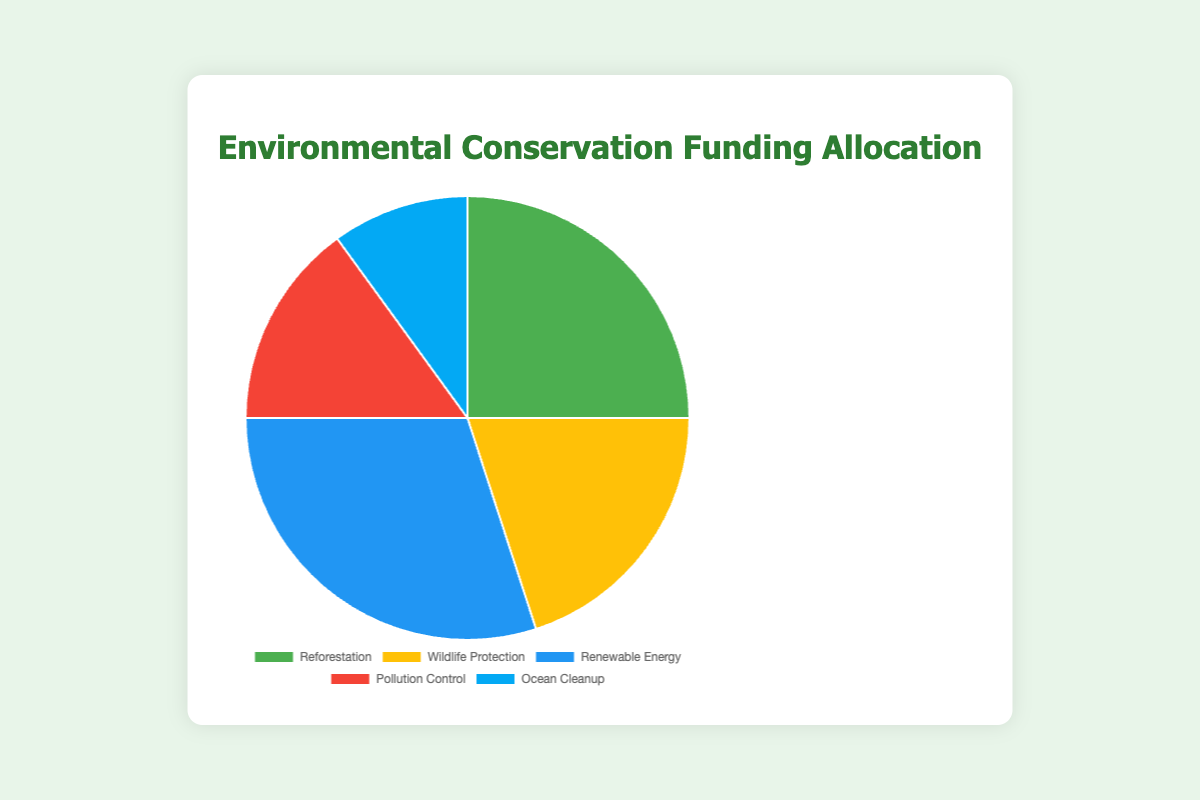What percentage of the funding goes toward Pollution Control? Locate the segment labeled "Pollution Control" on the pie chart. The label indicates that Pollution Control receives 15% of the total funding.
Answer: 15% Which type of project receives the largest allocation of funding? Check the proportions of each segment in the pie chart. The "Renewable Energy" segment is the largest, with 30% of the total funding.
Answer: Renewable Energy How much more funding does Renewable Energy get compared to Ocean Cleanup? Renewable Energy has 30% and Ocean Cleanup has 10%. Subtract 10% from 30% to find the difference.
Answer: 20% What is the combined percentage allocation for Reforestation and Wildlife Protection? Reforestation is allocated 25% and Wildlife Protection is allocated 20%. Add these two percentages together. 25% + 20% = 45%
Answer: 45% Which project type receives the least funding? Identify the smallest segment in the pie chart. The "Ocean Cleanup" segment, with 10%, is the smallest.
Answer: Ocean Cleanup Is the total funding for Pollution Control and Ocean Cleanup less than the funding for Renewable Energy? Pollution Control has 15% and Ocean Cleanup has 10%. Add these together to get 15% + 10% = 25%. Renewable Energy has 30%, which is more than 25%.
Answer: Yes How do the funding allocations for Wildlife Protection and Reforestation compare? Wildlife Protection has 20% and Reforestation has 25%. Reforestation receives 5% more funding than Wildlife Protection.
Answer: Reforestation gets 5% more What color represents the funding allocation for Reforestation on the pie chart? Find the segment labeled "Reforestation" and observe its color in the pie chart. It is green.
Answer: Green What is the average percentage allocation across all five project types? Add all the percentages together: 25% + 20% + 30% + 15% + 10% = 100%. Then divide by the number of project types (5). 100% / 5 = 20%
Answer: 20% Given that the total funding is $1,000,000, how much funding is allocated to Ocean Cleanup? Ocean Cleanup receives 10% of the total funding. Calculate 10% of $1,000,000: 0.10 * $1,000,000 = $100,000
Answer: $100,000 